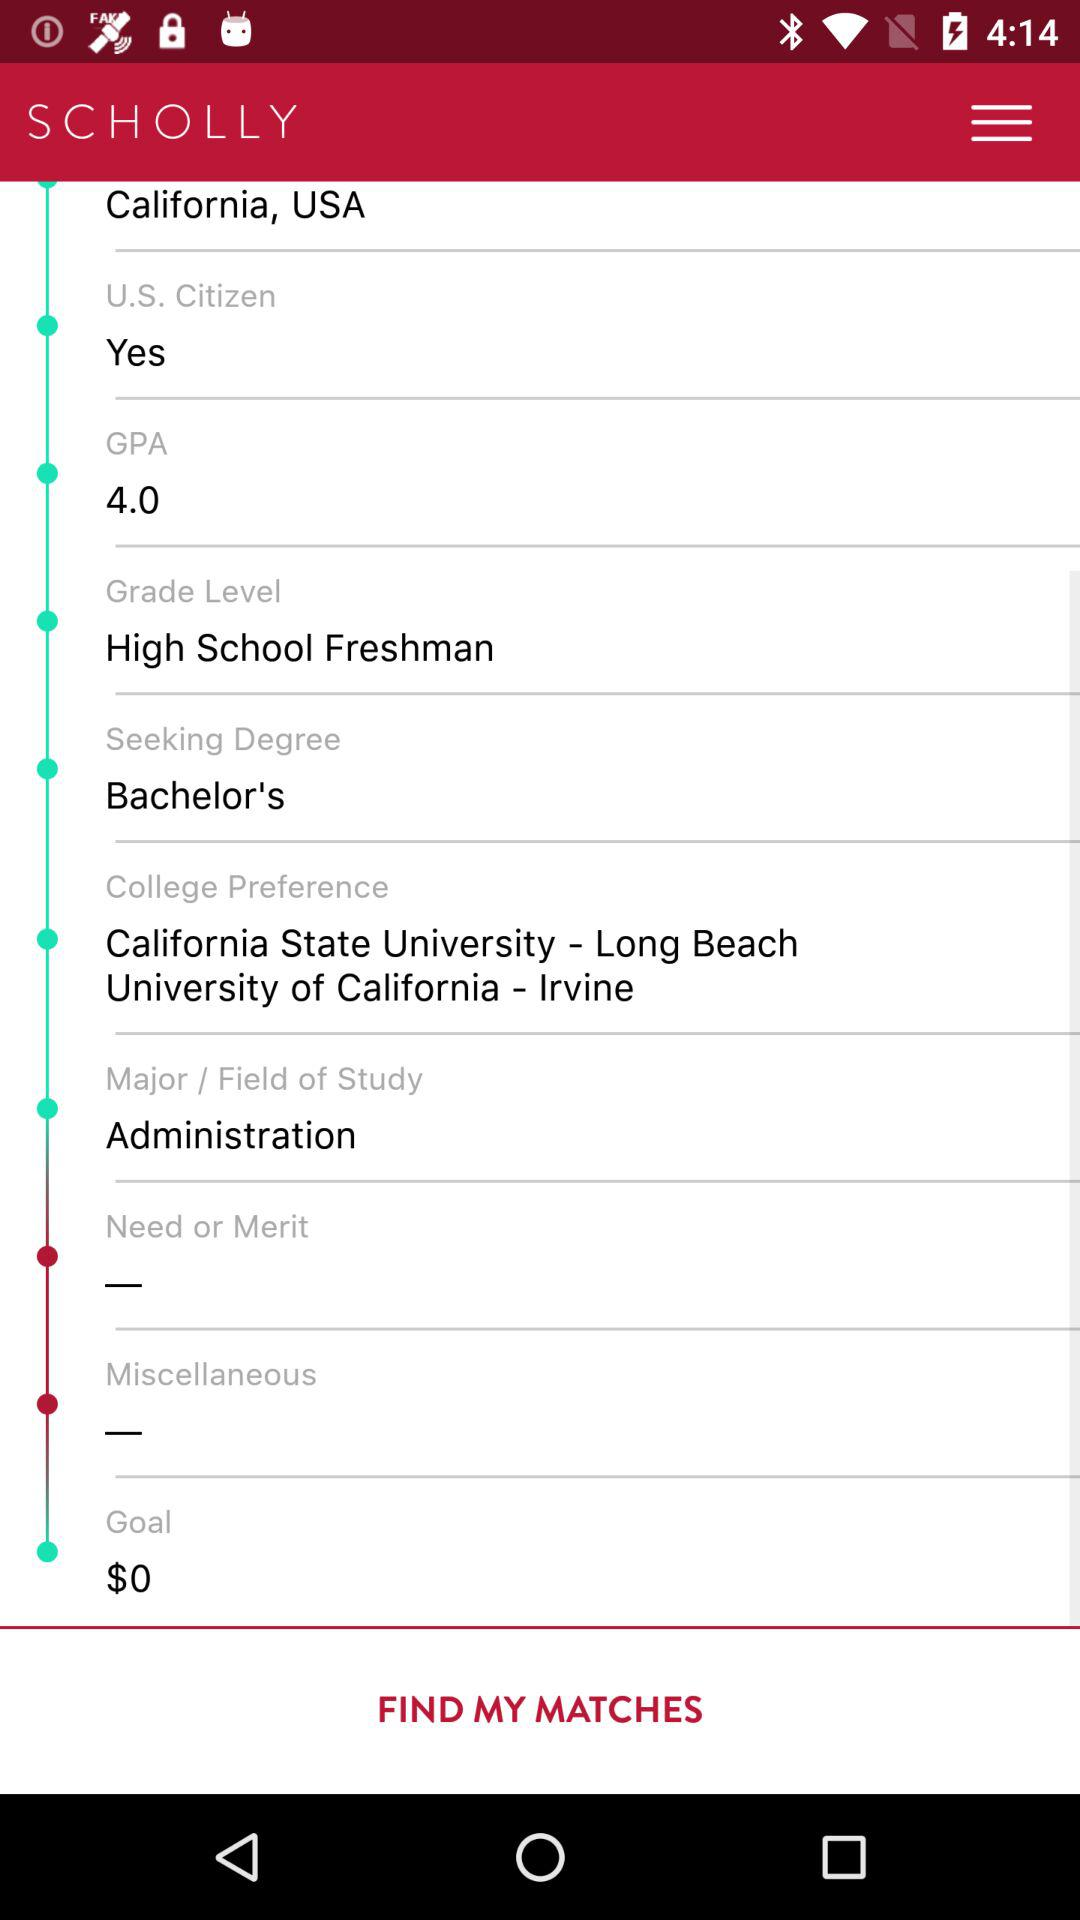What is the goal of the degree? The goal of the degree is $0. 